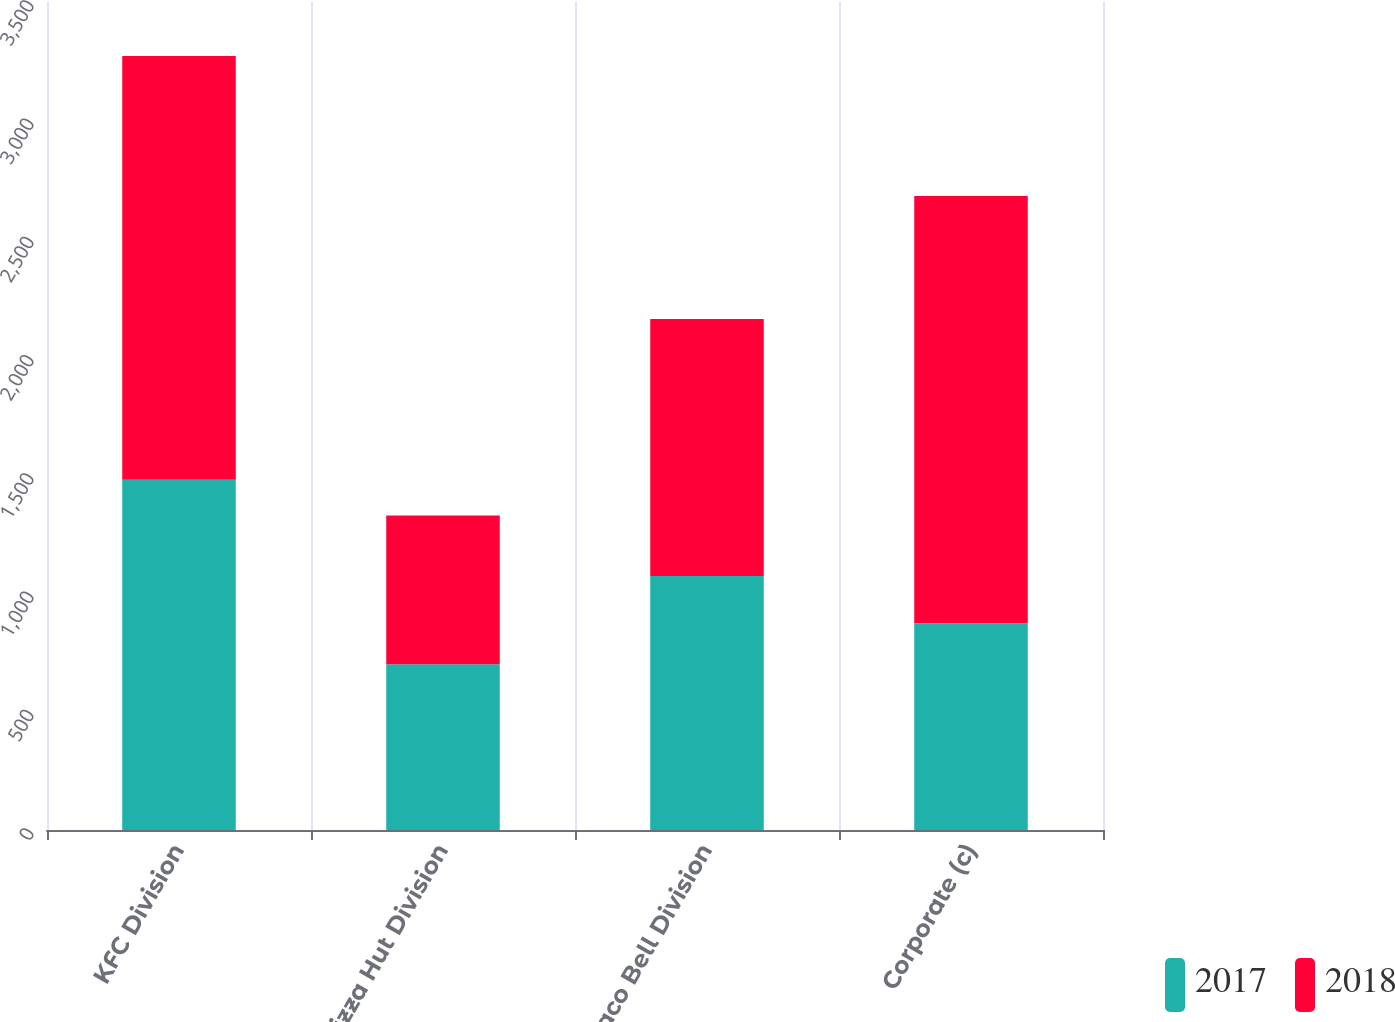Convert chart. <chart><loc_0><loc_0><loc_500><loc_500><stacked_bar_chart><ecel><fcel>KFC Division<fcel>Pizza Hut Division<fcel>Taco Bell Division<fcel>Corporate (c)<nl><fcel>2017<fcel>1481<fcel>701<fcel>1074<fcel>874<nl><fcel>2018<fcel>1791<fcel>628<fcel>1086<fcel>1806<nl></chart> 